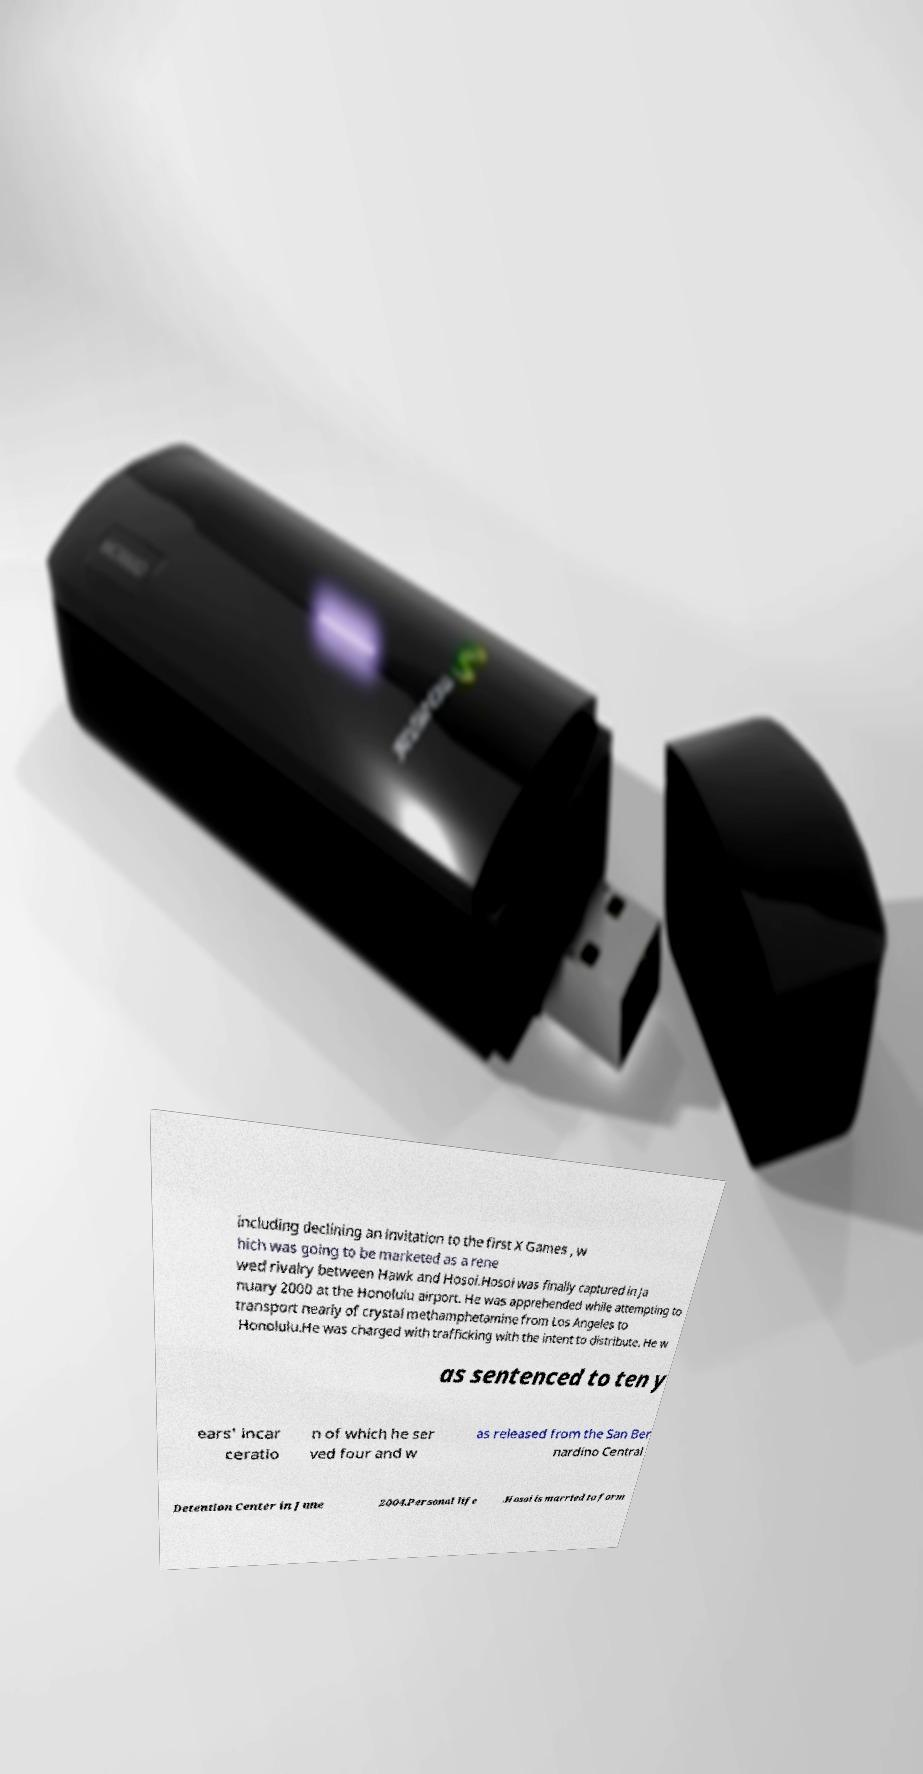There's text embedded in this image that I need extracted. Can you transcribe it verbatim? including declining an invitation to the first X Games , w hich was going to be marketed as a rene wed rivalry between Hawk and Hosoi.Hosoi was finally captured in Ja nuary 2000 at the Honolulu airport. He was apprehended while attempting to transport nearly of crystal methamphetamine from Los Angeles to Honolulu.He was charged with trafficking with the intent to distribute. He w as sentenced to ten y ears' incar ceratio n of which he ser ved four and w as released from the San Ber nardino Central Detention Center in June 2004.Personal life .Hosoi is married to form 